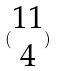<formula> <loc_0><loc_0><loc_500><loc_500>( \begin{matrix} 1 1 \\ 4 \end{matrix} )</formula> 